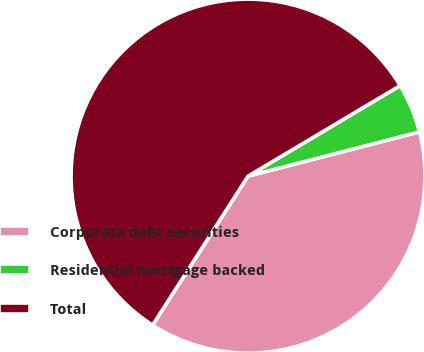<chart> <loc_0><loc_0><loc_500><loc_500><pie_chart><fcel>Corporate debt securities<fcel>Residential mortgage backed<fcel>Total<nl><fcel>38.09%<fcel>4.52%<fcel>57.39%<nl></chart> 